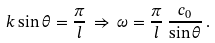<formula> <loc_0><loc_0><loc_500><loc_500>k \sin \theta = \frac { \pi } { l } \, \Rightarrow \, \omega = \frac { \pi } { l } \, \frac { c _ { 0 } } { \sin \theta } \, .</formula> 